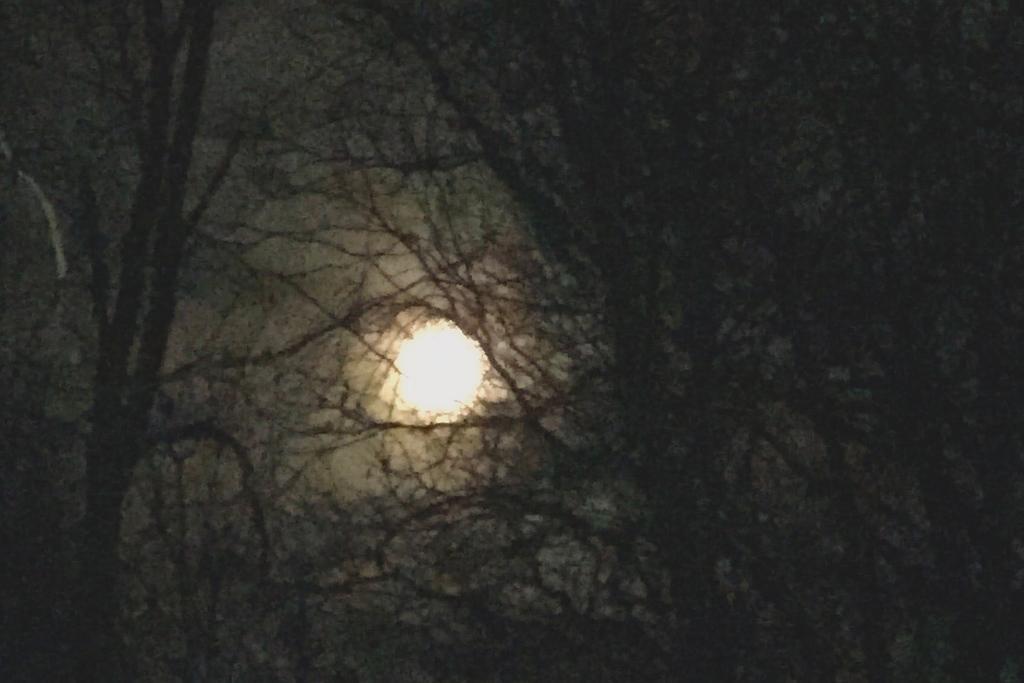In one or two sentences, can you explain what this image depicts? I can see this image is taken in dark time. There are trees and there is moon. 